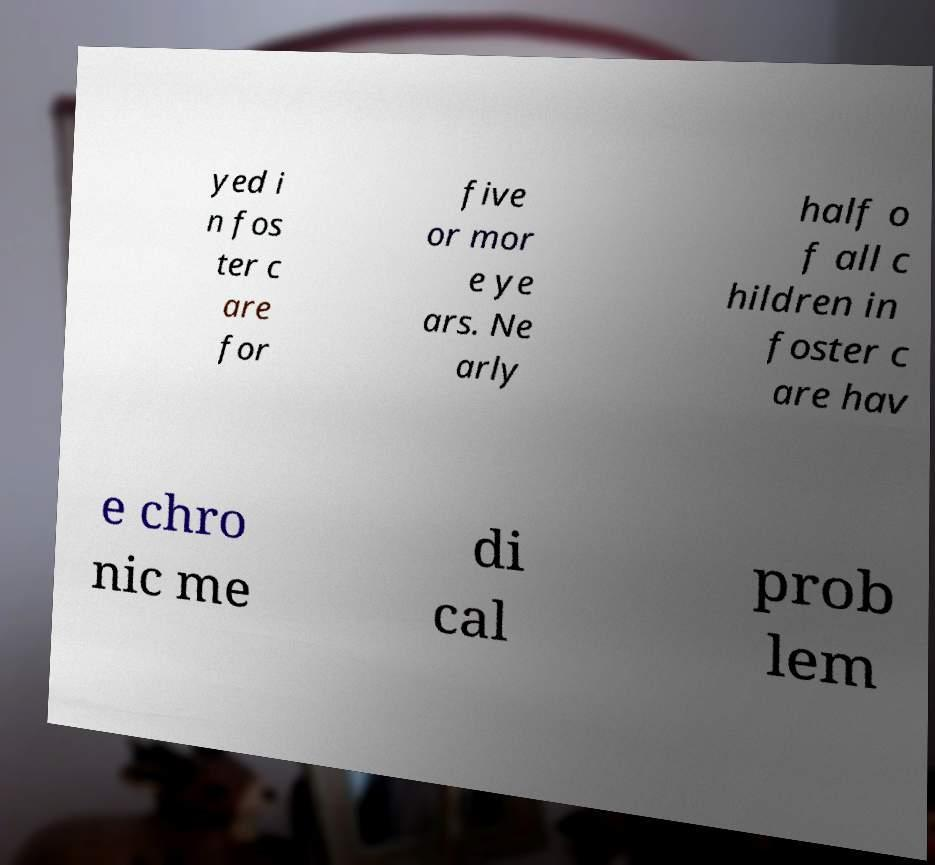What messages or text are displayed in this image? I need them in a readable, typed format. yed i n fos ter c are for five or mor e ye ars. Ne arly half o f all c hildren in foster c are hav e chro nic me di cal prob lem 